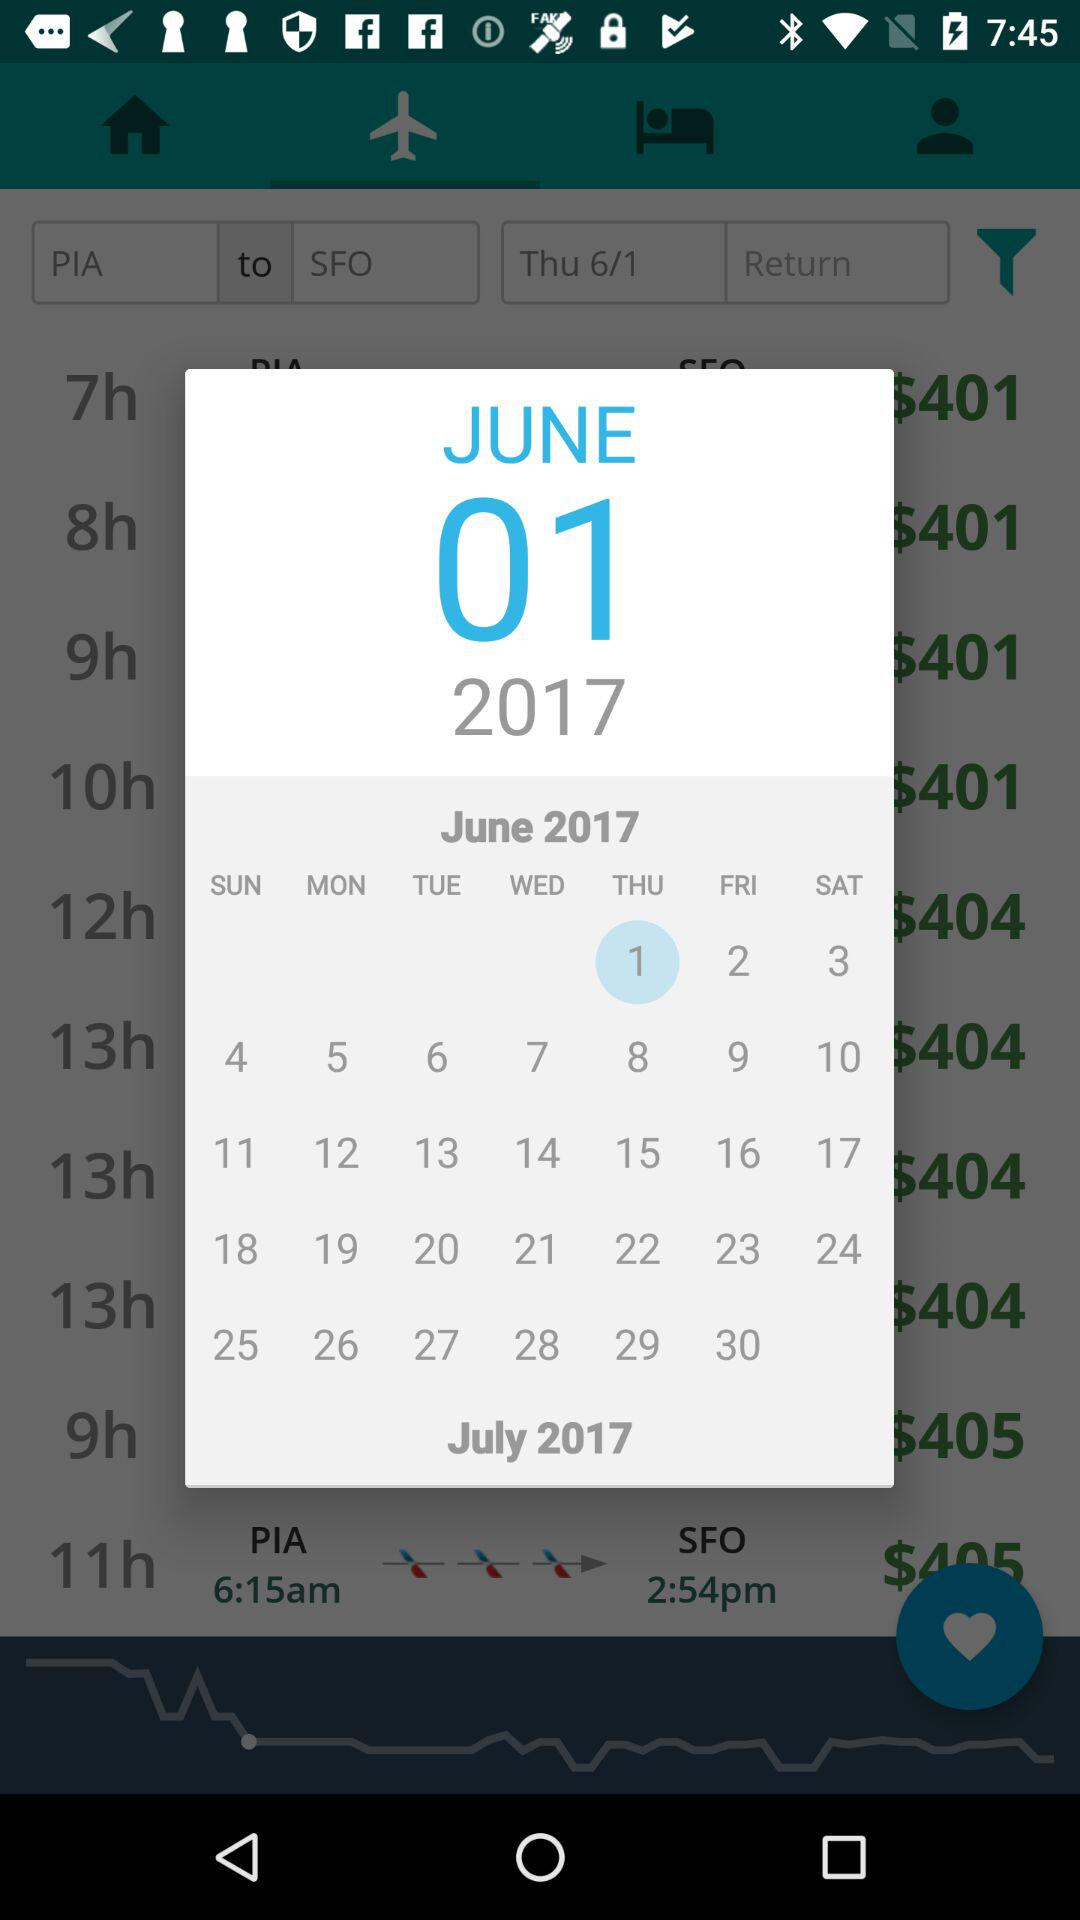What is the ticket price of a flight that takes 11 hours to reach SFO?
When the provided information is insufficient, respond with <no answer>. <no answer> 